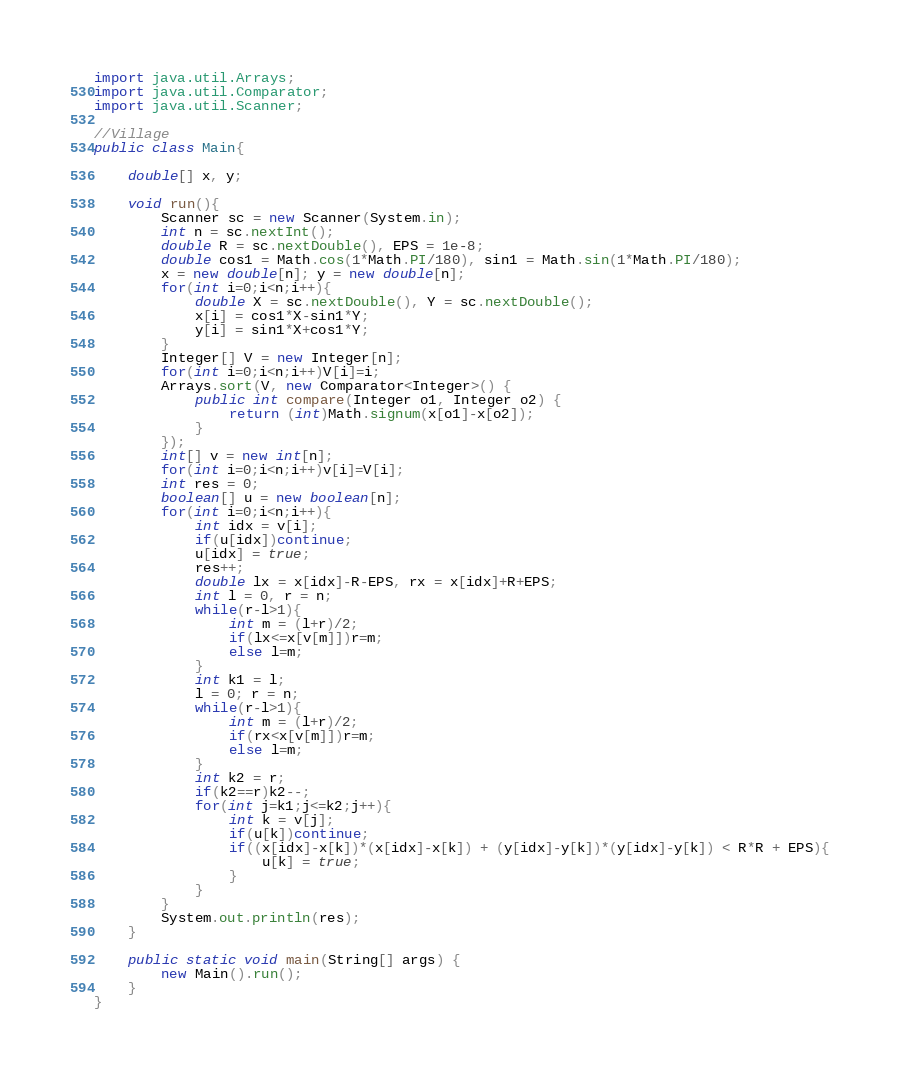Convert code to text. <code><loc_0><loc_0><loc_500><loc_500><_Java_>import java.util.Arrays;
import java.util.Comparator;
import java.util.Scanner;

//Village
public class Main{

	double[] x, y;
	
	void run(){
		Scanner sc = new Scanner(System.in);
		int n = sc.nextInt();
		double R = sc.nextDouble(), EPS = 1e-8;
		double cos1 = Math.cos(1*Math.PI/180), sin1 = Math.sin(1*Math.PI/180);
		x = new double[n]; y = new double[n];
		for(int i=0;i<n;i++){
			double X = sc.nextDouble(), Y = sc.nextDouble();
			x[i] = cos1*X-sin1*Y;
			y[i] = sin1*X+cos1*Y;
		}
		Integer[] V = new Integer[n];
		for(int i=0;i<n;i++)V[i]=i;
		Arrays.sort(V, new Comparator<Integer>() {
			public int compare(Integer o1, Integer o2) {
				return (int)Math.signum(x[o1]-x[o2]);
			}
		});
		int[] v = new int[n];
		for(int i=0;i<n;i++)v[i]=V[i];
		int res = 0;
		boolean[] u = new boolean[n];
		for(int i=0;i<n;i++){
			int idx = v[i];
			if(u[idx])continue;
			u[idx] = true;
			res++;
			double lx = x[idx]-R-EPS, rx = x[idx]+R+EPS;
			int l = 0, r = n;
			while(r-l>1){
				int m = (l+r)/2;
				if(lx<=x[v[m]])r=m;
				else l=m;
			}
			int k1 = l;
			l = 0; r = n;
			while(r-l>1){
				int m = (l+r)/2;
				if(rx<x[v[m]])r=m;
				else l=m;
			}
			int k2 = r;
			if(k2==r)k2--;
			for(int j=k1;j<=k2;j++){
				int k = v[j];
				if(u[k])continue;
				if((x[idx]-x[k])*(x[idx]-x[k]) + (y[idx]-y[k])*(y[idx]-y[k]) < R*R + EPS){
					u[k] = true;
				}
			}
		}
		System.out.println(res);
	}
	
	public static void main(String[] args) {
		new Main().run();
	}
}</code> 